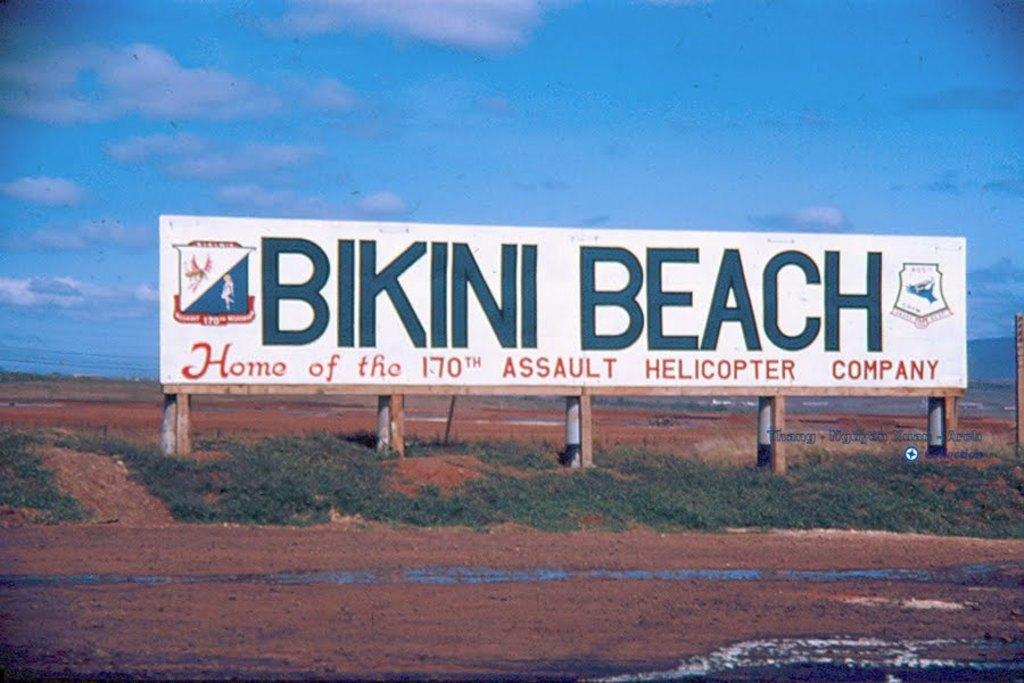<image>
Create a compact narrative representing the image presented. Billboard on the side of the road that says Bikini Beach. 